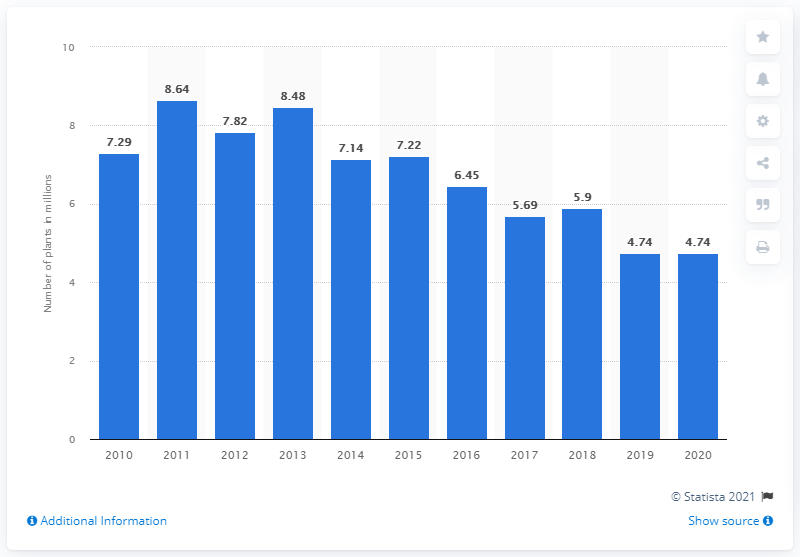Draw attention to some important aspects in this diagram. In 2020, a total of 4.74 million indoor potted poinsettias were produced in Canada. 